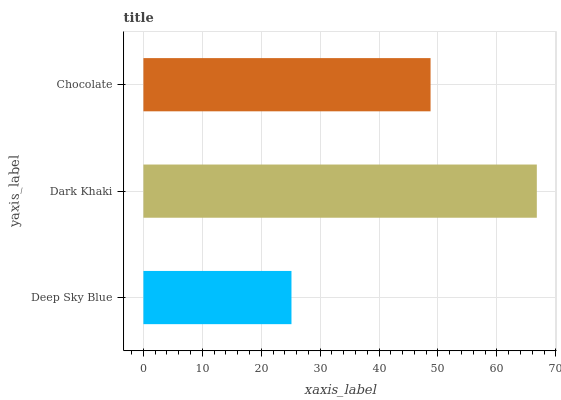Is Deep Sky Blue the minimum?
Answer yes or no. Yes. Is Dark Khaki the maximum?
Answer yes or no. Yes. Is Chocolate the minimum?
Answer yes or no. No. Is Chocolate the maximum?
Answer yes or no. No. Is Dark Khaki greater than Chocolate?
Answer yes or no. Yes. Is Chocolate less than Dark Khaki?
Answer yes or no. Yes. Is Chocolate greater than Dark Khaki?
Answer yes or no. No. Is Dark Khaki less than Chocolate?
Answer yes or no. No. Is Chocolate the high median?
Answer yes or no. Yes. Is Chocolate the low median?
Answer yes or no. Yes. Is Dark Khaki the high median?
Answer yes or no. No. Is Deep Sky Blue the low median?
Answer yes or no. No. 